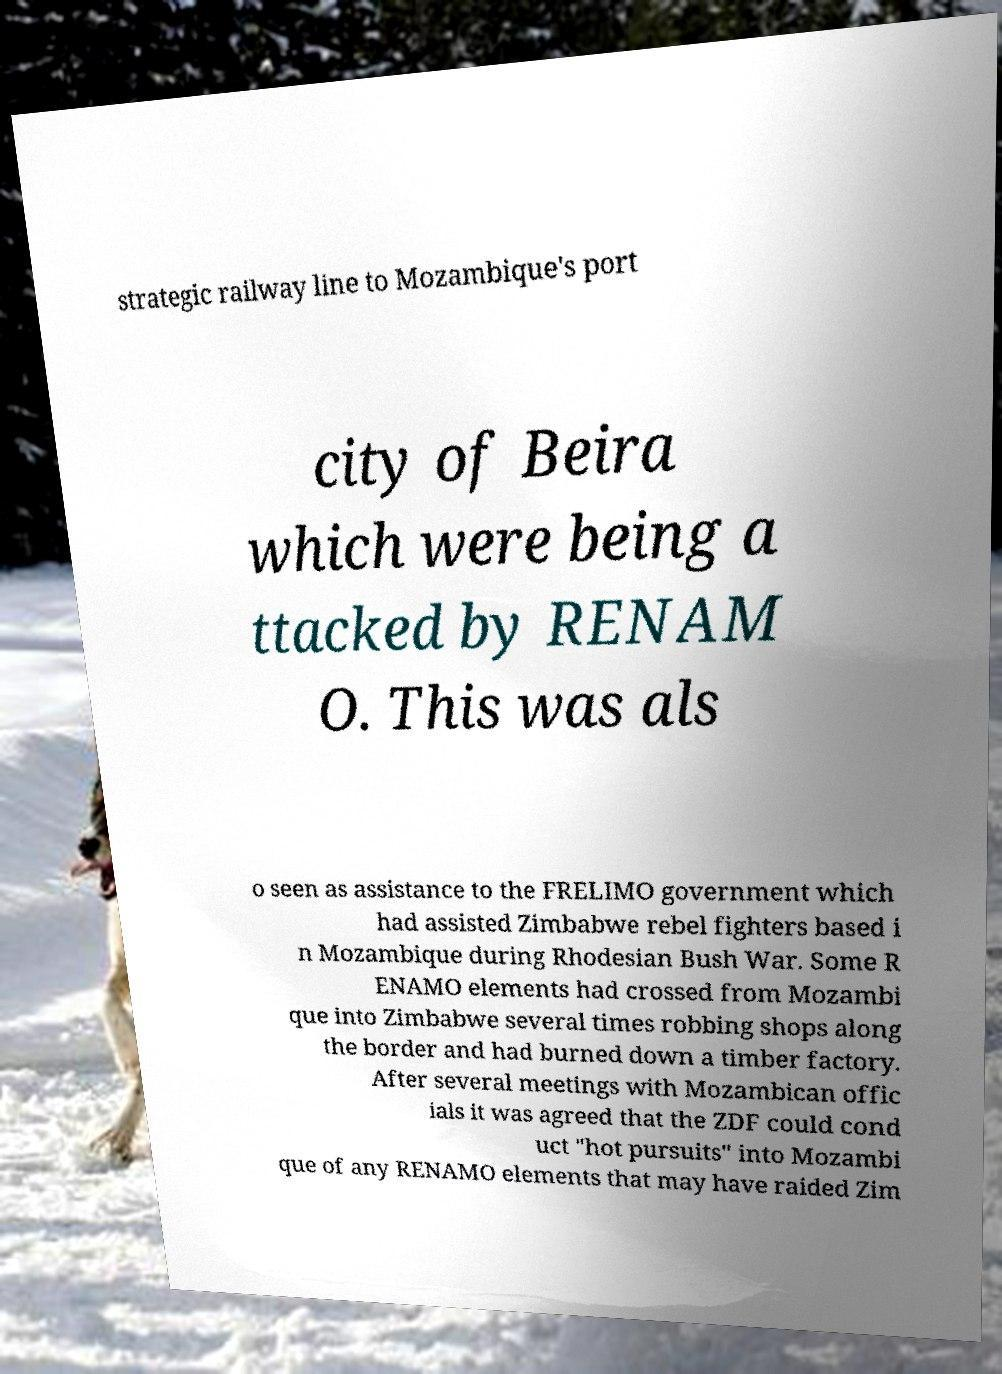Could you assist in decoding the text presented in this image and type it out clearly? strategic railway line to Mozambique's port city of Beira which were being a ttacked by RENAM O. This was als o seen as assistance to the FRELIMO government which had assisted Zimbabwe rebel fighters based i n Mozambique during Rhodesian Bush War. Some R ENAMO elements had crossed from Mozambi que into Zimbabwe several times robbing shops along the border and had burned down a timber factory. After several meetings with Mozambican offic ials it was agreed that the ZDF could cond uct "hot pursuits" into Mozambi que of any RENAMO elements that may have raided Zim 